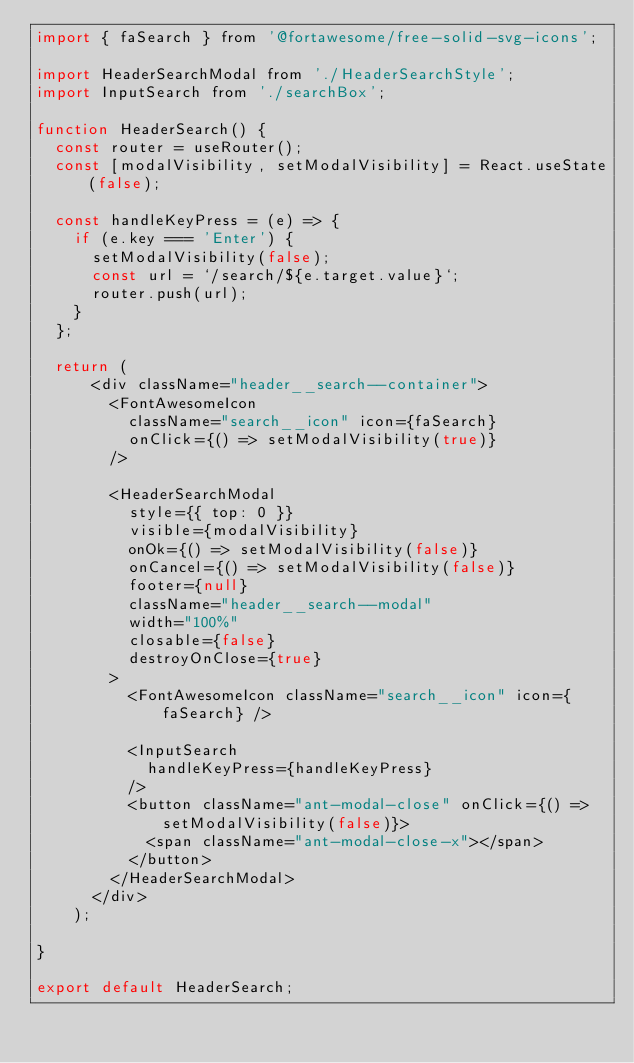<code> <loc_0><loc_0><loc_500><loc_500><_JavaScript_>import { faSearch } from '@fortawesome/free-solid-svg-icons';

import HeaderSearchModal from './HeaderSearchStyle';
import InputSearch from './searchBox';

function HeaderSearch() {
  const router = useRouter();
  const [modalVisibility, setModalVisibility] = React.useState(false);

  const handleKeyPress = (e) => {
    if (e.key === 'Enter') {
      setModalVisibility(false);
      const url = `/search/${e.target.value}`;
      router.push(url);
    }
  };

  return (
      <div className="header__search--container">
        <FontAwesomeIcon
          className="search__icon" icon={faSearch}
          onClick={() => setModalVisibility(true)}
        />

        <HeaderSearchModal
          style={{ top: 0 }}
          visible={modalVisibility}
          onOk={() => setModalVisibility(false)}
          onCancel={() => setModalVisibility(false)}
          footer={null}
          className="header__search--modal"
          width="100%"
          closable={false}
          destroyOnClose={true}
        >
          <FontAwesomeIcon className="search__icon" icon={faSearch} />

          <InputSearch
            handleKeyPress={handleKeyPress}
          />
          <button className="ant-modal-close" onClick={() => setModalVisibility(false)}>
            <span className="ant-modal-close-x"></span>
          </button>
        </HeaderSearchModal>
      </div>
    );

}

export default HeaderSearch;
</code> 